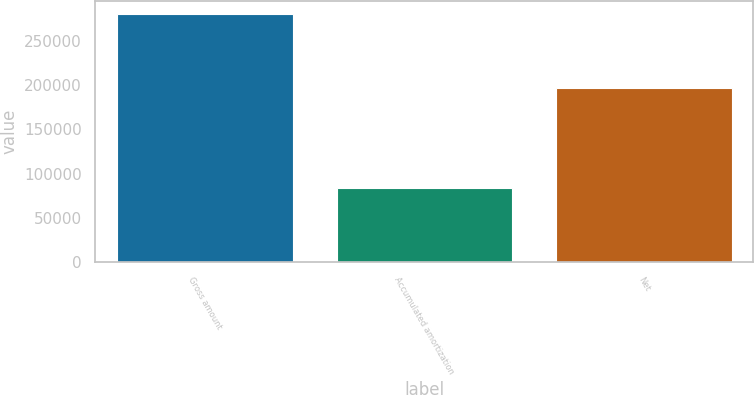Convert chart to OTSL. <chart><loc_0><loc_0><loc_500><loc_500><bar_chart><fcel>Gross amount<fcel>Accumulated amortization<fcel>Net<nl><fcel>280561<fcel>83547<fcel>197014<nl></chart> 